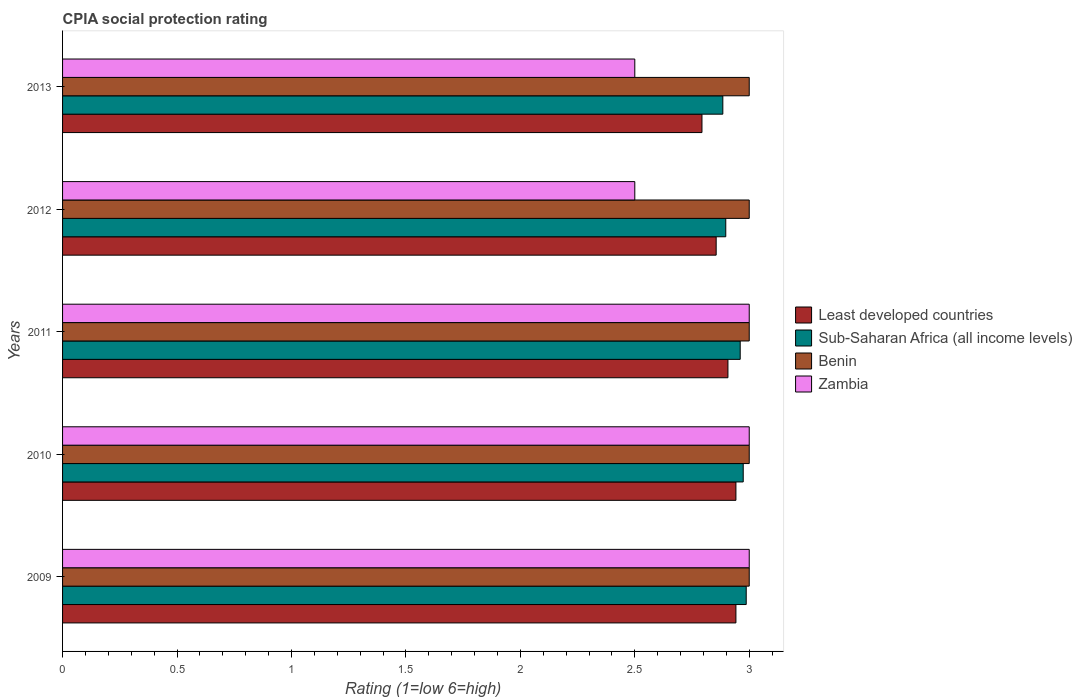How many different coloured bars are there?
Provide a short and direct response. 4. Are the number of bars per tick equal to the number of legend labels?
Provide a short and direct response. Yes. How many bars are there on the 4th tick from the bottom?
Your answer should be very brief. 4. What is the label of the 1st group of bars from the top?
Give a very brief answer. 2013. In how many cases, is the number of bars for a given year not equal to the number of legend labels?
Provide a short and direct response. 0. What is the CPIA rating in Benin in 2012?
Offer a very short reply. 3. Across all years, what is the maximum CPIA rating in Benin?
Offer a terse response. 3. Across all years, what is the minimum CPIA rating in Sub-Saharan Africa (all income levels)?
Make the answer very short. 2.88. What is the difference between the CPIA rating in Sub-Saharan Africa (all income levels) in 2009 and that in 2011?
Provide a succinct answer. 0.03. What is the average CPIA rating in Zambia per year?
Make the answer very short. 2.8. In the year 2010, what is the difference between the CPIA rating in Least developed countries and CPIA rating in Sub-Saharan Africa (all income levels)?
Provide a succinct answer. -0.03. What is the ratio of the CPIA rating in Zambia in 2010 to that in 2011?
Keep it short and to the point. 1. What is the difference between the highest and the second highest CPIA rating in Sub-Saharan Africa (all income levels)?
Your response must be concise. 0.01. What is the difference between the highest and the lowest CPIA rating in Zambia?
Your answer should be very brief. 0.5. What does the 1st bar from the top in 2012 represents?
Your response must be concise. Zambia. What does the 2nd bar from the bottom in 2009 represents?
Provide a succinct answer. Sub-Saharan Africa (all income levels). How many bars are there?
Your answer should be compact. 20. Are all the bars in the graph horizontal?
Your response must be concise. Yes. How many years are there in the graph?
Your answer should be compact. 5. Does the graph contain any zero values?
Ensure brevity in your answer.  No. Does the graph contain grids?
Keep it short and to the point. No. Where does the legend appear in the graph?
Provide a succinct answer. Center right. How many legend labels are there?
Ensure brevity in your answer.  4. How are the legend labels stacked?
Make the answer very short. Vertical. What is the title of the graph?
Offer a very short reply. CPIA social protection rating. Does "Liberia" appear as one of the legend labels in the graph?
Give a very brief answer. No. What is the label or title of the Y-axis?
Provide a succinct answer. Years. What is the Rating (1=low 6=high) of Least developed countries in 2009?
Your answer should be very brief. 2.94. What is the Rating (1=low 6=high) in Sub-Saharan Africa (all income levels) in 2009?
Your response must be concise. 2.99. What is the Rating (1=low 6=high) in Benin in 2009?
Offer a very short reply. 3. What is the Rating (1=low 6=high) in Least developed countries in 2010?
Ensure brevity in your answer.  2.94. What is the Rating (1=low 6=high) in Sub-Saharan Africa (all income levels) in 2010?
Ensure brevity in your answer.  2.97. What is the Rating (1=low 6=high) of Zambia in 2010?
Keep it short and to the point. 3. What is the Rating (1=low 6=high) of Least developed countries in 2011?
Offer a very short reply. 2.91. What is the Rating (1=low 6=high) in Sub-Saharan Africa (all income levels) in 2011?
Your response must be concise. 2.96. What is the Rating (1=low 6=high) in Benin in 2011?
Your answer should be compact. 3. What is the Rating (1=low 6=high) of Zambia in 2011?
Provide a short and direct response. 3. What is the Rating (1=low 6=high) of Least developed countries in 2012?
Provide a short and direct response. 2.86. What is the Rating (1=low 6=high) of Sub-Saharan Africa (all income levels) in 2012?
Provide a succinct answer. 2.9. What is the Rating (1=low 6=high) of Benin in 2012?
Provide a succinct answer. 3. What is the Rating (1=low 6=high) of Zambia in 2012?
Your answer should be very brief. 2.5. What is the Rating (1=low 6=high) of Least developed countries in 2013?
Your answer should be compact. 2.79. What is the Rating (1=low 6=high) of Sub-Saharan Africa (all income levels) in 2013?
Your answer should be compact. 2.88. Across all years, what is the maximum Rating (1=low 6=high) in Least developed countries?
Your answer should be compact. 2.94. Across all years, what is the maximum Rating (1=low 6=high) in Sub-Saharan Africa (all income levels)?
Offer a very short reply. 2.99. Across all years, what is the minimum Rating (1=low 6=high) in Least developed countries?
Offer a terse response. 2.79. Across all years, what is the minimum Rating (1=low 6=high) of Sub-Saharan Africa (all income levels)?
Your answer should be very brief. 2.88. Across all years, what is the minimum Rating (1=low 6=high) in Zambia?
Ensure brevity in your answer.  2.5. What is the total Rating (1=low 6=high) in Least developed countries in the graph?
Ensure brevity in your answer.  14.44. What is the total Rating (1=low 6=high) in Sub-Saharan Africa (all income levels) in the graph?
Your answer should be compact. 14.7. What is the total Rating (1=low 6=high) in Benin in the graph?
Provide a succinct answer. 15. What is the total Rating (1=low 6=high) of Zambia in the graph?
Your response must be concise. 14. What is the difference between the Rating (1=low 6=high) in Least developed countries in 2009 and that in 2010?
Your answer should be compact. 0. What is the difference between the Rating (1=low 6=high) in Sub-Saharan Africa (all income levels) in 2009 and that in 2010?
Provide a succinct answer. 0.01. What is the difference between the Rating (1=low 6=high) in Benin in 2009 and that in 2010?
Ensure brevity in your answer.  0. What is the difference between the Rating (1=low 6=high) in Zambia in 2009 and that in 2010?
Offer a very short reply. 0. What is the difference between the Rating (1=low 6=high) in Least developed countries in 2009 and that in 2011?
Give a very brief answer. 0.03. What is the difference between the Rating (1=low 6=high) of Sub-Saharan Africa (all income levels) in 2009 and that in 2011?
Give a very brief answer. 0.03. What is the difference between the Rating (1=low 6=high) of Least developed countries in 2009 and that in 2012?
Make the answer very short. 0.09. What is the difference between the Rating (1=low 6=high) of Sub-Saharan Africa (all income levels) in 2009 and that in 2012?
Ensure brevity in your answer.  0.09. What is the difference between the Rating (1=low 6=high) in Benin in 2009 and that in 2012?
Ensure brevity in your answer.  0. What is the difference between the Rating (1=low 6=high) in Zambia in 2009 and that in 2012?
Give a very brief answer. 0.5. What is the difference between the Rating (1=low 6=high) in Least developed countries in 2009 and that in 2013?
Your response must be concise. 0.15. What is the difference between the Rating (1=low 6=high) in Sub-Saharan Africa (all income levels) in 2009 and that in 2013?
Keep it short and to the point. 0.1. What is the difference between the Rating (1=low 6=high) of Zambia in 2009 and that in 2013?
Keep it short and to the point. 0.5. What is the difference between the Rating (1=low 6=high) in Least developed countries in 2010 and that in 2011?
Offer a terse response. 0.03. What is the difference between the Rating (1=low 6=high) of Sub-Saharan Africa (all income levels) in 2010 and that in 2011?
Make the answer very short. 0.01. What is the difference between the Rating (1=low 6=high) in Benin in 2010 and that in 2011?
Your answer should be very brief. 0. What is the difference between the Rating (1=low 6=high) in Zambia in 2010 and that in 2011?
Give a very brief answer. 0. What is the difference between the Rating (1=low 6=high) of Least developed countries in 2010 and that in 2012?
Make the answer very short. 0.09. What is the difference between the Rating (1=low 6=high) in Sub-Saharan Africa (all income levels) in 2010 and that in 2012?
Ensure brevity in your answer.  0.08. What is the difference between the Rating (1=low 6=high) in Benin in 2010 and that in 2012?
Your answer should be very brief. 0. What is the difference between the Rating (1=low 6=high) in Zambia in 2010 and that in 2012?
Offer a terse response. 0.5. What is the difference between the Rating (1=low 6=high) of Least developed countries in 2010 and that in 2013?
Provide a short and direct response. 0.15. What is the difference between the Rating (1=low 6=high) of Sub-Saharan Africa (all income levels) in 2010 and that in 2013?
Ensure brevity in your answer.  0.09. What is the difference between the Rating (1=low 6=high) in Least developed countries in 2011 and that in 2012?
Keep it short and to the point. 0.05. What is the difference between the Rating (1=low 6=high) in Sub-Saharan Africa (all income levels) in 2011 and that in 2012?
Keep it short and to the point. 0.06. What is the difference between the Rating (1=low 6=high) in Benin in 2011 and that in 2012?
Provide a succinct answer. 0. What is the difference between the Rating (1=low 6=high) of Zambia in 2011 and that in 2012?
Make the answer very short. 0.5. What is the difference between the Rating (1=low 6=high) of Least developed countries in 2011 and that in 2013?
Your answer should be compact. 0.11. What is the difference between the Rating (1=low 6=high) in Sub-Saharan Africa (all income levels) in 2011 and that in 2013?
Provide a succinct answer. 0.08. What is the difference between the Rating (1=low 6=high) of Benin in 2011 and that in 2013?
Your answer should be very brief. 0. What is the difference between the Rating (1=low 6=high) of Zambia in 2011 and that in 2013?
Provide a succinct answer. 0.5. What is the difference between the Rating (1=low 6=high) in Least developed countries in 2012 and that in 2013?
Your answer should be compact. 0.06. What is the difference between the Rating (1=low 6=high) of Sub-Saharan Africa (all income levels) in 2012 and that in 2013?
Offer a terse response. 0.01. What is the difference between the Rating (1=low 6=high) of Benin in 2012 and that in 2013?
Offer a terse response. 0. What is the difference between the Rating (1=low 6=high) in Least developed countries in 2009 and the Rating (1=low 6=high) in Sub-Saharan Africa (all income levels) in 2010?
Ensure brevity in your answer.  -0.03. What is the difference between the Rating (1=low 6=high) of Least developed countries in 2009 and the Rating (1=low 6=high) of Benin in 2010?
Keep it short and to the point. -0.06. What is the difference between the Rating (1=low 6=high) in Least developed countries in 2009 and the Rating (1=low 6=high) in Zambia in 2010?
Keep it short and to the point. -0.06. What is the difference between the Rating (1=low 6=high) of Sub-Saharan Africa (all income levels) in 2009 and the Rating (1=low 6=high) of Benin in 2010?
Offer a very short reply. -0.01. What is the difference between the Rating (1=low 6=high) in Sub-Saharan Africa (all income levels) in 2009 and the Rating (1=low 6=high) in Zambia in 2010?
Ensure brevity in your answer.  -0.01. What is the difference between the Rating (1=low 6=high) of Benin in 2009 and the Rating (1=low 6=high) of Zambia in 2010?
Provide a short and direct response. 0. What is the difference between the Rating (1=low 6=high) in Least developed countries in 2009 and the Rating (1=low 6=high) in Sub-Saharan Africa (all income levels) in 2011?
Ensure brevity in your answer.  -0.02. What is the difference between the Rating (1=low 6=high) in Least developed countries in 2009 and the Rating (1=low 6=high) in Benin in 2011?
Give a very brief answer. -0.06. What is the difference between the Rating (1=low 6=high) in Least developed countries in 2009 and the Rating (1=low 6=high) in Zambia in 2011?
Offer a terse response. -0.06. What is the difference between the Rating (1=low 6=high) of Sub-Saharan Africa (all income levels) in 2009 and the Rating (1=low 6=high) of Benin in 2011?
Keep it short and to the point. -0.01. What is the difference between the Rating (1=low 6=high) in Sub-Saharan Africa (all income levels) in 2009 and the Rating (1=low 6=high) in Zambia in 2011?
Ensure brevity in your answer.  -0.01. What is the difference between the Rating (1=low 6=high) of Benin in 2009 and the Rating (1=low 6=high) of Zambia in 2011?
Your response must be concise. 0. What is the difference between the Rating (1=low 6=high) in Least developed countries in 2009 and the Rating (1=low 6=high) in Sub-Saharan Africa (all income levels) in 2012?
Make the answer very short. 0.04. What is the difference between the Rating (1=low 6=high) in Least developed countries in 2009 and the Rating (1=low 6=high) in Benin in 2012?
Ensure brevity in your answer.  -0.06. What is the difference between the Rating (1=low 6=high) in Least developed countries in 2009 and the Rating (1=low 6=high) in Zambia in 2012?
Provide a succinct answer. 0.44. What is the difference between the Rating (1=low 6=high) in Sub-Saharan Africa (all income levels) in 2009 and the Rating (1=low 6=high) in Benin in 2012?
Your response must be concise. -0.01. What is the difference between the Rating (1=low 6=high) of Sub-Saharan Africa (all income levels) in 2009 and the Rating (1=low 6=high) of Zambia in 2012?
Offer a very short reply. 0.49. What is the difference between the Rating (1=low 6=high) in Least developed countries in 2009 and the Rating (1=low 6=high) in Sub-Saharan Africa (all income levels) in 2013?
Make the answer very short. 0.06. What is the difference between the Rating (1=low 6=high) in Least developed countries in 2009 and the Rating (1=low 6=high) in Benin in 2013?
Make the answer very short. -0.06. What is the difference between the Rating (1=low 6=high) of Least developed countries in 2009 and the Rating (1=low 6=high) of Zambia in 2013?
Your response must be concise. 0.44. What is the difference between the Rating (1=low 6=high) in Sub-Saharan Africa (all income levels) in 2009 and the Rating (1=low 6=high) in Benin in 2013?
Ensure brevity in your answer.  -0.01. What is the difference between the Rating (1=low 6=high) of Sub-Saharan Africa (all income levels) in 2009 and the Rating (1=low 6=high) of Zambia in 2013?
Make the answer very short. 0.49. What is the difference between the Rating (1=low 6=high) of Benin in 2009 and the Rating (1=low 6=high) of Zambia in 2013?
Your answer should be compact. 0.5. What is the difference between the Rating (1=low 6=high) of Least developed countries in 2010 and the Rating (1=low 6=high) of Sub-Saharan Africa (all income levels) in 2011?
Provide a succinct answer. -0.02. What is the difference between the Rating (1=low 6=high) of Least developed countries in 2010 and the Rating (1=low 6=high) of Benin in 2011?
Your response must be concise. -0.06. What is the difference between the Rating (1=low 6=high) of Least developed countries in 2010 and the Rating (1=low 6=high) of Zambia in 2011?
Provide a succinct answer. -0.06. What is the difference between the Rating (1=low 6=high) of Sub-Saharan Africa (all income levels) in 2010 and the Rating (1=low 6=high) of Benin in 2011?
Offer a terse response. -0.03. What is the difference between the Rating (1=low 6=high) of Sub-Saharan Africa (all income levels) in 2010 and the Rating (1=low 6=high) of Zambia in 2011?
Offer a terse response. -0.03. What is the difference between the Rating (1=low 6=high) of Benin in 2010 and the Rating (1=low 6=high) of Zambia in 2011?
Offer a terse response. 0. What is the difference between the Rating (1=low 6=high) of Least developed countries in 2010 and the Rating (1=low 6=high) of Sub-Saharan Africa (all income levels) in 2012?
Your answer should be compact. 0.04. What is the difference between the Rating (1=low 6=high) in Least developed countries in 2010 and the Rating (1=low 6=high) in Benin in 2012?
Keep it short and to the point. -0.06. What is the difference between the Rating (1=low 6=high) in Least developed countries in 2010 and the Rating (1=low 6=high) in Zambia in 2012?
Offer a very short reply. 0.44. What is the difference between the Rating (1=low 6=high) of Sub-Saharan Africa (all income levels) in 2010 and the Rating (1=low 6=high) of Benin in 2012?
Your response must be concise. -0.03. What is the difference between the Rating (1=low 6=high) of Sub-Saharan Africa (all income levels) in 2010 and the Rating (1=low 6=high) of Zambia in 2012?
Provide a succinct answer. 0.47. What is the difference between the Rating (1=low 6=high) of Benin in 2010 and the Rating (1=low 6=high) of Zambia in 2012?
Offer a very short reply. 0.5. What is the difference between the Rating (1=low 6=high) of Least developed countries in 2010 and the Rating (1=low 6=high) of Sub-Saharan Africa (all income levels) in 2013?
Give a very brief answer. 0.06. What is the difference between the Rating (1=low 6=high) in Least developed countries in 2010 and the Rating (1=low 6=high) in Benin in 2013?
Make the answer very short. -0.06. What is the difference between the Rating (1=low 6=high) in Least developed countries in 2010 and the Rating (1=low 6=high) in Zambia in 2013?
Give a very brief answer. 0.44. What is the difference between the Rating (1=low 6=high) in Sub-Saharan Africa (all income levels) in 2010 and the Rating (1=low 6=high) in Benin in 2013?
Give a very brief answer. -0.03. What is the difference between the Rating (1=low 6=high) of Sub-Saharan Africa (all income levels) in 2010 and the Rating (1=low 6=high) of Zambia in 2013?
Keep it short and to the point. 0.47. What is the difference between the Rating (1=low 6=high) of Least developed countries in 2011 and the Rating (1=low 6=high) of Sub-Saharan Africa (all income levels) in 2012?
Offer a very short reply. 0.01. What is the difference between the Rating (1=low 6=high) of Least developed countries in 2011 and the Rating (1=low 6=high) of Benin in 2012?
Provide a short and direct response. -0.09. What is the difference between the Rating (1=low 6=high) in Least developed countries in 2011 and the Rating (1=low 6=high) in Zambia in 2012?
Make the answer very short. 0.41. What is the difference between the Rating (1=low 6=high) of Sub-Saharan Africa (all income levels) in 2011 and the Rating (1=low 6=high) of Benin in 2012?
Your answer should be very brief. -0.04. What is the difference between the Rating (1=low 6=high) of Sub-Saharan Africa (all income levels) in 2011 and the Rating (1=low 6=high) of Zambia in 2012?
Make the answer very short. 0.46. What is the difference between the Rating (1=low 6=high) of Least developed countries in 2011 and the Rating (1=low 6=high) of Sub-Saharan Africa (all income levels) in 2013?
Offer a very short reply. 0.02. What is the difference between the Rating (1=low 6=high) in Least developed countries in 2011 and the Rating (1=low 6=high) in Benin in 2013?
Make the answer very short. -0.09. What is the difference between the Rating (1=low 6=high) in Least developed countries in 2011 and the Rating (1=low 6=high) in Zambia in 2013?
Make the answer very short. 0.41. What is the difference between the Rating (1=low 6=high) of Sub-Saharan Africa (all income levels) in 2011 and the Rating (1=low 6=high) of Benin in 2013?
Provide a succinct answer. -0.04. What is the difference between the Rating (1=low 6=high) of Sub-Saharan Africa (all income levels) in 2011 and the Rating (1=low 6=high) of Zambia in 2013?
Your answer should be very brief. 0.46. What is the difference between the Rating (1=low 6=high) of Benin in 2011 and the Rating (1=low 6=high) of Zambia in 2013?
Give a very brief answer. 0.5. What is the difference between the Rating (1=low 6=high) of Least developed countries in 2012 and the Rating (1=low 6=high) of Sub-Saharan Africa (all income levels) in 2013?
Your answer should be very brief. -0.03. What is the difference between the Rating (1=low 6=high) in Least developed countries in 2012 and the Rating (1=low 6=high) in Benin in 2013?
Offer a terse response. -0.14. What is the difference between the Rating (1=low 6=high) in Least developed countries in 2012 and the Rating (1=low 6=high) in Zambia in 2013?
Your answer should be compact. 0.36. What is the difference between the Rating (1=low 6=high) of Sub-Saharan Africa (all income levels) in 2012 and the Rating (1=low 6=high) of Benin in 2013?
Your answer should be very brief. -0.1. What is the difference between the Rating (1=low 6=high) of Sub-Saharan Africa (all income levels) in 2012 and the Rating (1=low 6=high) of Zambia in 2013?
Keep it short and to the point. 0.4. What is the difference between the Rating (1=low 6=high) in Benin in 2012 and the Rating (1=low 6=high) in Zambia in 2013?
Provide a short and direct response. 0.5. What is the average Rating (1=low 6=high) of Least developed countries per year?
Your response must be concise. 2.89. What is the average Rating (1=low 6=high) of Sub-Saharan Africa (all income levels) per year?
Your answer should be very brief. 2.94. In the year 2009, what is the difference between the Rating (1=low 6=high) in Least developed countries and Rating (1=low 6=high) in Sub-Saharan Africa (all income levels)?
Your answer should be compact. -0.04. In the year 2009, what is the difference between the Rating (1=low 6=high) of Least developed countries and Rating (1=low 6=high) of Benin?
Provide a short and direct response. -0.06. In the year 2009, what is the difference between the Rating (1=low 6=high) in Least developed countries and Rating (1=low 6=high) in Zambia?
Keep it short and to the point. -0.06. In the year 2009, what is the difference between the Rating (1=low 6=high) in Sub-Saharan Africa (all income levels) and Rating (1=low 6=high) in Benin?
Your response must be concise. -0.01. In the year 2009, what is the difference between the Rating (1=low 6=high) in Sub-Saharan Africa (all income levels) and Rating (1=low 6=high) in Zambia?
Your answer should be very brief. -0.01. In the year 2009, what is the difference between the Rating (1=low 6=high) in Benin and Rating (1=low 6=high) in Zambia?
Provide a succinct answer. 0. In the year 2010, what is the difference between the Rating (1=low 6=high) of Least developed countries and Rating (1=low 6=high) of Sub-Saharan Africa (all income levels)?
Your answer should be very brief. -0.03. In the year 2010, what is the difference between the Rating (1=low 6=high) in Least developed countries and Rating (1=low 6=high) in Benin?
Your answer should be compact. -0.06. In the year 2010, what is the difference between the Rating (1=low 6=high) of Least developed countries and Rating (1=low 6=high) of Zambia?
Offer a terse response. -0.06. In the year 2010, what is the difference between the Rating (1=low 6=high) of Sub-Saharan Africa (all income levels) and Rating (1=low 6=high) of Benin?
Your response must be concise. -0.03. In the year 2010, what is the difference between the Rating (1=low 6=high) in Sub-Saharan Africa (all income levels) and Rating (1=low 6=high) in Zambia?
Provide a succinct answer. -0.03. In the year 2010, what is the difference between the Rating (1=low 6=high) in Benin and Rating (1=low 6=high) in Zambia?
Provide a short and direct response. 0. In the year 2011, what is the difference between the Rating (1=low 6=high) in Least developed countries and Rating (1=low 6=high) in Sub-Saharan Africa (all income levels)?
Ensure brevity in your answer.  -0.05. In the year 2011, what is the difference between the Rating (1=low 6=high) of Least developed countries and Rating (1=low 6=high) of Benin?
Make the answer very short. -0.09. In the year 2011, what is the difference between the Rating (1=low 6=high) in Least developed countries and Rating (1=low 6=high) in Zambia?
Provide a succinct answer. -0.09. In the year 2011, what is the difference between the Rating (1=low 6=high) in Sub-Saharan Africa (all income levels) and Rating (1=low 6=high) in Benin?
Ensure brevity in your answer.  -0.04. In the year 2011, what is the difference between the Rating (1=low 6=high) in Sub-Saharan Africa (all income levels) and Rating (1=low 6=high) in Zambia?
Your response must be concise. -0.04. In the year 2011, what is the difference between the Rating (1=low 6=high) of Benin and Rating (1=low 6=high) of Zambia?
Provide a succinct answer. 0. In the year 2012, what is the difference between the Rating (1=low 6=high) of Least developed countries and Rating (1=low 6=high) of Sub-Saharan Africa (all income levels)?
Offer a very short reply. -0.04. In the year 2012, what is the difference between the Rating (1=low 6=high) in Least developed countries and Rating (1=low 6=high) in Benin?
Offer a very short reply. -0.14. In the year 2012, what is the difference between the Rating (1=low 6=high) of Least developed countries and Rating (1=low 6=high) of Zambia?
Give a very brief answer. 0.36. In the year 2012, what is the difference between the Rating (1=low 6=high) in Sub-Saharan Africa (all income levels) and Rating (1=low 6=high) in Benin?
Your response must be concise. -0.1. In the year 2012, what is the difference between the Rating (1=low 6=high) in Sub-Saharan Africa (all income levels) and Rating (1=low 6=high) in Zambia?
Your answer should be very brief. 0.4. In the year 2012, what is the difference between the Rating (1=low 6=high) of Benin and Rating (1=low 6=high) of Zambia?
Keep it short and to the point. 0.5. In the year 2013, what is the difference between the Rating (1=low 6=high) in Least developed countries and Rating (1=low 6=high) in Sub-Saharan Africa (all income levels)?
Provide a succinct answer. -0.09. In the year 2013, what is the difference between the Rating (1=low 6=high) in Least developed countries and Rating (1=low 6=high) in Benin?
Provide a short and direct response. -0.21. In the year 2013, what is the difference between the Rating (1=low 6=high) of Least developed countries and Rating (1=low 6=high) of Zambia?
Your answer should be very brief. 0.29. In the year 2013, what is the difference between the Rating (1=low 6=high) in Sub-Saharan Africa (all income levels) and Rating (1=low 6=high) in Benin?
Your response must be concise. -0.12. In the year 2013, what is the difference between the Rating (1=low 6=high) of Sub-Saharan Africa (all income levels) and Rating (1=low 6=high) of Zambia?
Provide a short and direct response. 0.38. What is the ratio of the Rating (1=low 6=high) of Benin in 2009 to that in 2010?
Make the answer very short. 1. What is the ratio of the Rating (1=low 6=high) in Zambia in 2009 to that in 2010?
Keep it short and to the point. 1. What is the ratio of the Rating (1=low 6=high) in Least developed countries in 2009 to that in 2011?
Provide a short and direct response. 1.01. What is the ratio of the Rating (1=low 6=high) of Sub-Saharan Africa (all income levels) in 2009 to that in 2011?
Your answer should be very brief. 1.01. What is the ratio of the Rating (1=low 6=high) in Zambia in 2009 to that in 2011?
Provide a succinct answer. 1. What is the ratio of the Rating (1=low 6=high) of Least developed countries in 2009 to that in 2012?
Your answer should be very brief. 1.03. What is the ratio of the Rating (1=low 6=high) of Sub-Saharan Africa (all income levels) in 2009 to that in 2012?
Keep it short and to the point. 1.03. What is the ratio of the Rating (1=low 6=high) of Benin in 2009 to that in 2012?
Give a very brief answer. 1. What is the ratio of the Rating (1=low 6=high) in Zambia in 2009 to that in 2012?
Your response must be concise. 1.2. What is the ratio of the Rating (1=low 6=high) in Least developed countries in 2009 to that in 2013?
Provide a short and direct response. 1.05. What is the ratio of the Rating (1=low 6=high) in Sub-Saharan Africa (all income levels) in 2009 to that in 2013?
Offer a terse response. 1.04. What is the ratio of the Rating (1=low 6=high) in Zambia in 2009 to that in 2013?
Offer a terse response. 1.2. What is the ratio of the Rating (1=low 6=high) of Benin in 2010 to that in 2011?
Keep it short and to the point. 1. What is the ratio of the Rating (1=low 6=high) of Zambia in 2010 to that in 2011?
Make the answer very short. 1. What is the ratio of the Rating (1=low 6=high) of Least developed countries in 2010 to that in 2012?
Ensure brevity in your answer.  1.03. What is the ratio of the Rating (1=low 6=high) in Sub-Saharan Africa (all income levels) in 2010 to that in 2012?
Offer a terse response. 1.03. What is the ratio of the Rating (1=low 6=high) of Zambia in 2010 to that in 2012?
Give a very brief answer. 1.2. What is the ratio of the Rating (1=low 6=high) in Least developed countries in 2010 to that in 2013?
Offer a very short reply. 1.05. What is the ratio of the Rating (1=low 6=high) of Sub-Saharan Africa (all income levels) in 2010 to that in 2013?
Offer a very short reply. 1.03. What is the ratio of the Rating (1=low 6=high) of Benin in 2010 to that in 2013?
Your answer should be very brief. 1. What is the ratio of the Rating (1=low 6=high) of Sub-Saharan Africa (all income levels) in 2011 to that in 2012?
Your answer should be very brief. 1.02. What is the ratio of the Rating (1=low 6=high) of Benin in 2011 to that in 2012?
Keep it short and to the point. 1. What is the ratio of the Rating (1=low 6=high) of Zambia in 2011 to that in 2012?
Ensure brevity in your answer.  1.2. What is the ratio of the Rating (1=low 6=high) of Least developed countries in 2011 to that in 2013?
Provide a succinct answer. 1.04. What is the ratio of the Rating (1=low 6=high) of Sub-Saharan Africa (all income levels) in 2011 to that in 2013?
Ensure brevity in your answer.  1.03. What is the ratio of the Rating (1=low 6=high) in Least developed countries in 2012 to that in 2013?
Your response must be concise. 1.02. What is the ratio of the Rating (1=low 6=high) of Sub-Saharan Africa (all income levels) in 2012 to that in 2013?
Offer a very short reply. 1. What is the ratio of the Rating (1=low 6=high) of Benin in 2012 to that in 2013?
Provide a short and direct response. 1. What is the difference between the highest and the second highest Rating (1=low 6=high) in Least developed countries?
Make the answer very short. 0. What is the difference between the highest and the second highest Rating (1=low 6=high) of Sub-Saharan Africa (all income levels)?
Provide a succinct answer. 0.01. What is the difference between the highest and the lowest Rating (1=low 6=high) of Least developed countries?
Make the answer very short. 0.15. What is the difference between the highest and the lowest Rating (1=low 6=high) of Sub-Saharan Africa (all income levels)?
Provide a succinct answer. 0.1. 